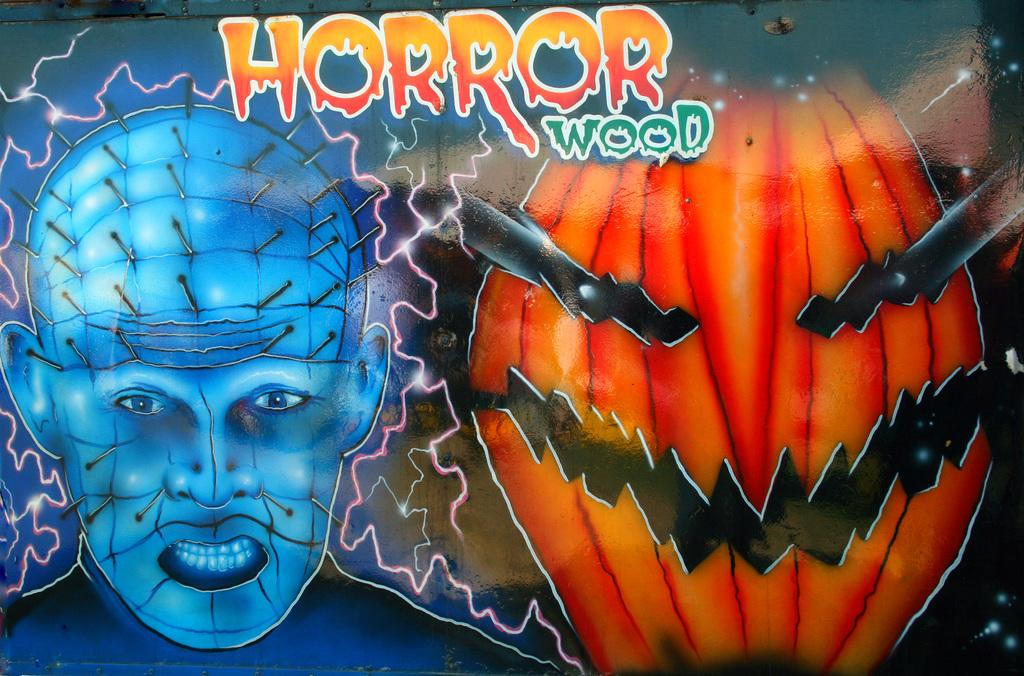What can be seen in the image? There are pictures and text in the image. Can you describe the pictures in the image? Unfortunately, the provided facts do not give any details about the pictures, so we cannot describe them. What does the text in the image say? The provided facts do not give any details about the text, so we cannot determine what it says. Is there a knife being used to set off the alarm in the image? There is no mention of an alarm or a knife in the provided facts, so we cannot determine if they are present or interacting in the image. 